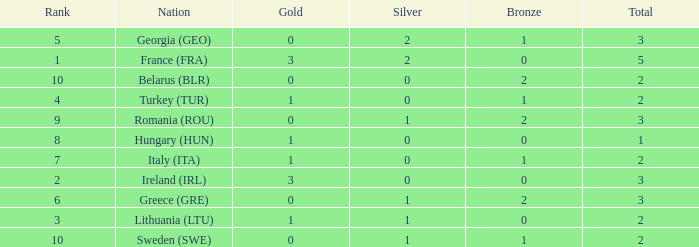What's the rank of Turkey (TUR) with a total more than 2? 0.0. 